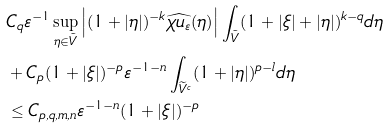Convert formula to latex. <formula><loc_0><loc_0><loc_500><loc_500>& C _ { q } \varepsilon ^ { - 1 } \sup _ { \eta \in \tilde { V } } \left | ( 1 + | \eta | ) ^ { - k } \widehat { \chi u _ { \varepsilon } } ( \eta ) \right | \int _ { \tilde { V } } ( 1 + | \xi | + | \eta | ) ^ { k - q } d \eta \\ & + C _ { p } ( 1 + | \xi | ) ^ { - p } \varepsilon ^ { - 1 - n } \int _ { \widetilde { V } ^ { c } } ( 1 + | \eta | ) ^ { p - l } d \eta \\ & \leq C _ { p , q , m , n } \varepsilon ^ { - 1 - n } ( 1 + | \xi | ) ^ { - p }</formula> 